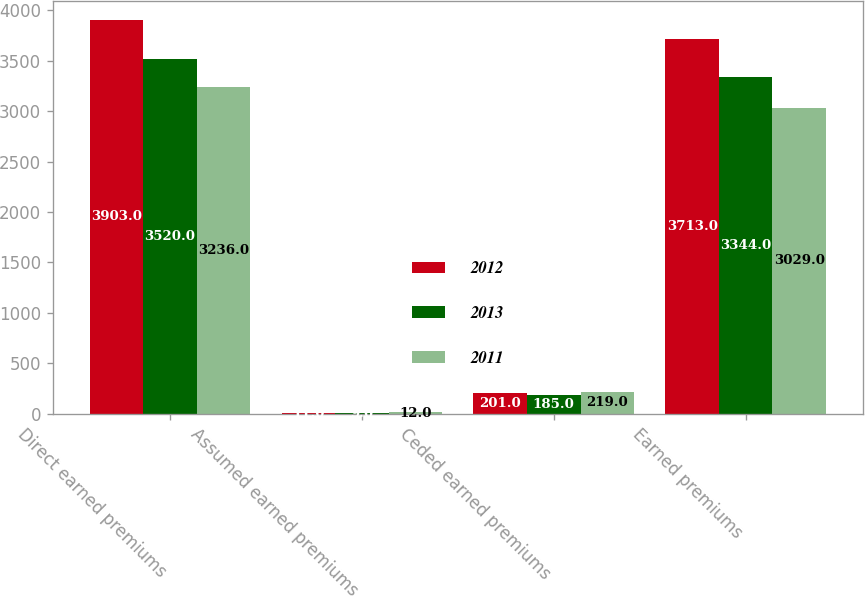Convert chart. <chart><loc_0><loc_0><loc_500><loc_500><stacked_bar_chart><ecel><fcel>Direct earned premiums<fcel>Assumed earned premiums<fcel>Ceded earned premiums<fcel>Earned premiums<nl><fcel>2012<fcel>3903<fcel>11<fcel>201<fcel>3713<nl><fcel>2013<fcel>3520<fcel>9<fcel>185<fcel>3344<nl><fcel>2011<fcel>3236<fcel>12<fcel>219<fcel>3029<nl></chart> 